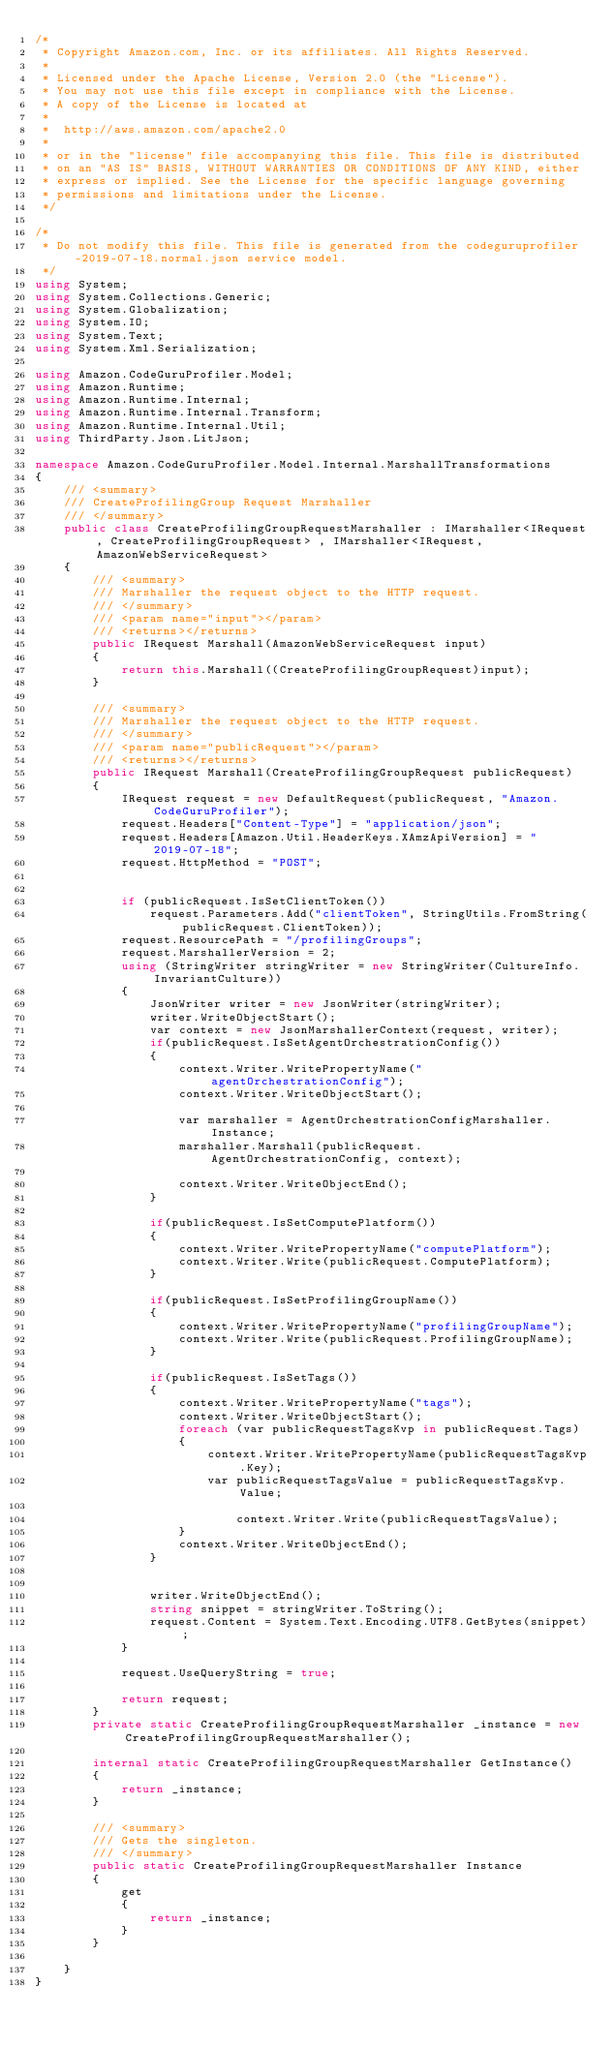Convert code to text. <code><loc_0><loc_0><loc_500><loc_500><_C#_>/*
 * Copyright Amazon.com, Inc. or its affiliates. All Rights Reserved.
 * 
 * Licensed under the Apache License, Version 2.0 (the "License").
 * You may not use this file except in compliance with the License.
 * A copy of the License is located at
 * 
 *  http://aws.amazon.com/apache2.0
 * 
 * or in the "license" file accompanying this file. This file is distributed
 * on an "AS IS" BASIS, WITHOUT WARRANTIES OR CONDITIONS OF ANY KIND, either
 * express or implied. See the License for the specific language governing
 * permissions and limitations under the License.
 */

/*
 * Do not modify this file. This file is generated from the codeguruprofiler-2019-07-18.normal.json service model.
 */
using System;
using System.Collections.Generic;
using System.Globalization;
using System.IO;
using System.Text;
using System.Xml.Serialization;

using Amazon.CodeGuruProfiler.Model;
using Amazon.Runtime;
using Amazon.Runtime.Internal;
using Amazon.Runtime.Internal.Transform;
using Amazon.Runtime.Internal.Util;
using ThirdParty.Json.LitJson;

namespace Amazon.CodeGuruProfiler.Model.Internal.MarshallTransformations
{
    /// <summary>
    /// CreateProfilingGroup Request Marshaller
    /// </summary>       
    public class CreateProfilingGroupRequestMarshaller : IMarshaller<IRequest, CreateProfilingGroupRequest> , IMarshaller<IRequest,AmazonWebServiceRequest>
    {
        /// <summary>
        /// Marshaller the request object to the HTTP request.
        /// </summary>  
        /// <param name="input"></param>
        /// <returns></returns>
        public IRequest Marshall(AmazonWebServiceRequest input)
        {
            return this.Marshall((CreateProfilingGroupRequest)input);
        }

        /// <summary>
        /// Marshaller the request object to the HTTP request.
        /// </summary>  
        /// <param name="publicRequest"></param>
        /// <returns></returns>
        public IRequest Marshall(CreateProfilingGroupRequest publicRequest)
        {
            IRequest request = new DefaultRequest(publicRequest, "Amazon.CodeGuruProfiler");
            request.Headers["Content-Type"] = "application/json";
            request.Headers[Amazon.Util.HeaderKeys.XAmzApiVersion] = "2019-07-18";            
            request.HttpMethod = "POST";

            
            if (publicRequest.IsSetClientToken())
                request.Parameters.Add("clientToken", StringUtils.FromString(publicRequest.ClientToken));
            request.ResourcePath = "/profilingGroups";
            request.MarshallerVersion = 2;
            using (StringWriter stringWriter = new StringWriter(CultureInfo.InvariantCulture))
            {
                JsonWriter writer = new JsonWriter(stringWriter);
                writer.WriteObjectStart();
                var context = new JsonMarshallerContext(request, writer);
                if(publicRequest.IsSetAgentOrchestrationConfig())
                {
                    context.Writer.WritePropertyName("agentOrchestrationConfig");
                    context.Writer.WriteObjectStart();

                    var marshaller = AgentOrchestrationConfigMarshaller.Instance;
                    marshaller.Marshall(publicRequest.AgentOrchestrationConfig, context);

                    context.Writer.WriteObjectEnd();
                }

                if(publicRequest.IsSetComputePlatform())
                {
                    context.Writer.WritePropertyName("computePlatform");
                    context.Writer.Write(publicRequest.ComputePlatform);
                }

                if(publicRequest.IsSetProfilingGroupName())
                {
                    context.Writer.WritePropertyName("profilingGroupName");
                    context.Writer.Write(publicRequest.ProfilingGroupName);
                }

                if(publicRequest.IsSetTags())
                {
                    context.Writer.WritePropertyName("tags");
                    context.Writer.WriteObjectStart();
                    foreach (var publicRequestTagsKvp in publicRequest.Tags)
                    {
                        context.Writer.WritePropertyName(publicRequestTagsKvp.Key);
                        var publicRequestTagsValue = publicRequestTagsKvp.Value;

                            context.Writer.Write(publicRequestTagsValue);
                    }
                    context.Writer.WriteObjectEnd();
                }

        
                writer.WriteObjectEnd();
                string snippet = stringWriter.ToString();
                request.Content = System.Text.Encoding.UTF8.GetBytes(snippet);
            }

            request.UseQueryString = true;

            return request;
        }
        private static CreateProfilingGroupRequestMarshaller _instance = new CreateProfilingGroupRequestMarshaller();        

        internal static CreateProfilingGroupRequestMarshaller GetInstance()
        {
            return _instance;
        }

        /// <summary>
        /// Gets the singleton.
        /// </summary>  
        public static CreateProfilingGroupRequestMarshaller Instance
        {
            get
            {
                return _instance;
            }
        }

    }
}</code> 